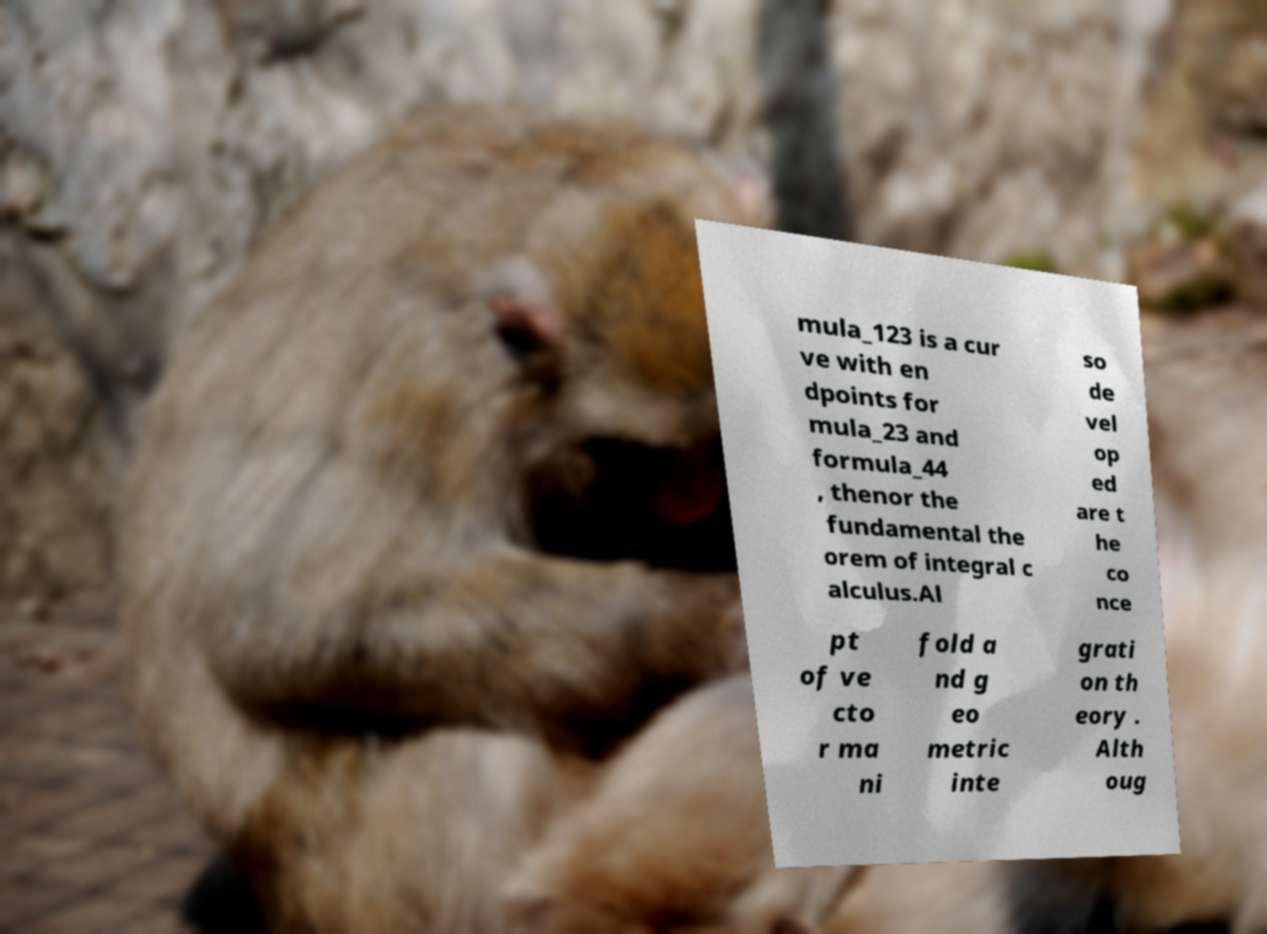I need the written content from this picture converted into text. Can you do that? mula_123 is a cur ve with en dpoints for mula_23 and formula_44 , thenor the fundamental the orem of integral c alculus.Al so de vel op ed are t he co nce pt of ve cto r ma ni fold a nd g eo metric inte grati on th eory . Alth oug 